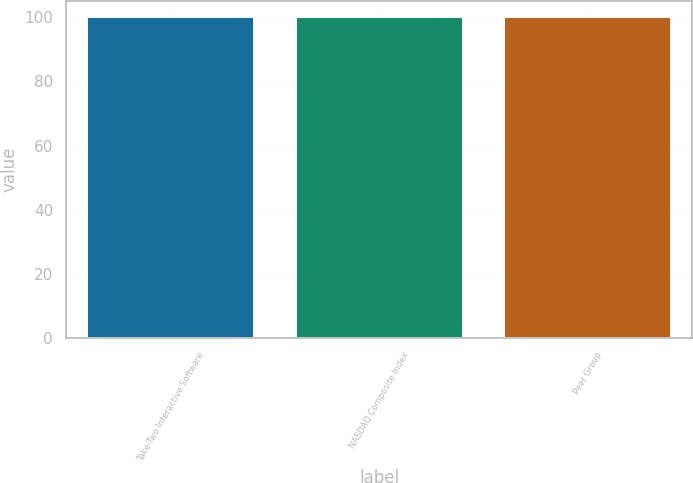<chart> <loc_0><loc_0><loc_500><loc_500><bar_chart><fcel>Take-Two Interactive Software<fcel>NASDAQ Composite Index<fcel>Peer Group<nl><fcel>100<fcel>100.1<fcel>100.2<nl></chart> 